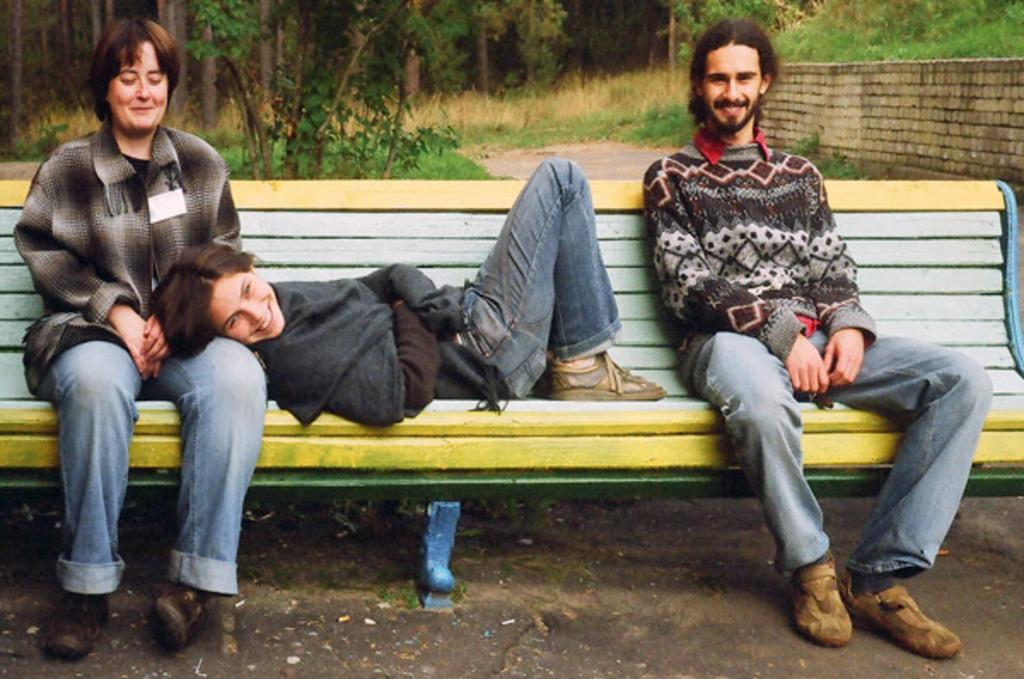What is happening on the left side of the image? There is a woman sitting on a bench on the left side of the image, and a girl is sleeping on the woman. What is the man on the right side of the image doing? The man is sitting on a bench on the right side of the image, and he is smiling. What can be seen in the background of the image? There is a wall and trees in the background of the image. What is the distance between the woman and the minister in the image? There is no minister present in the image, so it is not possible to determine the distance between the woman and a minister. What type of string is being used by the girl in the image? There is no string present in the image; the girl is sleeping on the woman. 